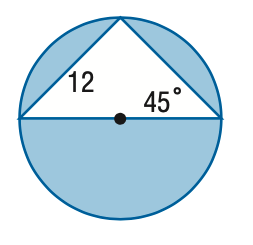Question: Find the area of the shaded region. Round to the nearest tenth.
Choices:
A. 41.1
B. 82.2
C. 154.2
D. 267.3
Answer with the letter. Answer: C 